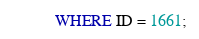Convert code to text. <code><loc_0><loc_0><loc_500><loc_500><_SQL_>WHERE ID = 1661;
</code> 